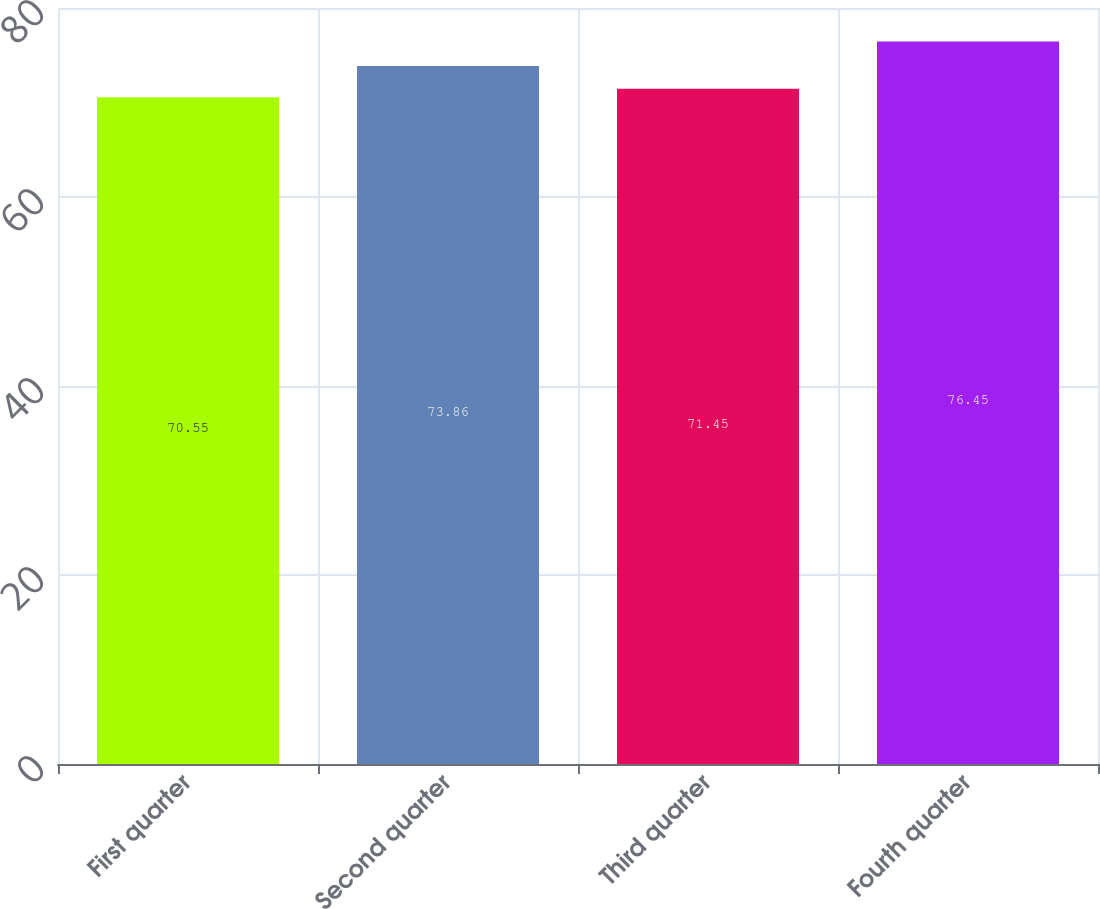Convert chart to OTSL. <chart><loc_0><loc_0><loc_500><loc_500><bar_chart><fcel>First quarter<fcel>Second quarter<fcel>Third quarter<fcel>Fourth quarter<nl><fcel>70.55<fcel>73.86<fcel>71.45<fcel>76.45<nl></chart> 